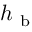Convert formula to latex. <formula><loc_0><loc_0><loc_500><loc_500>h _ { b }</formula> 